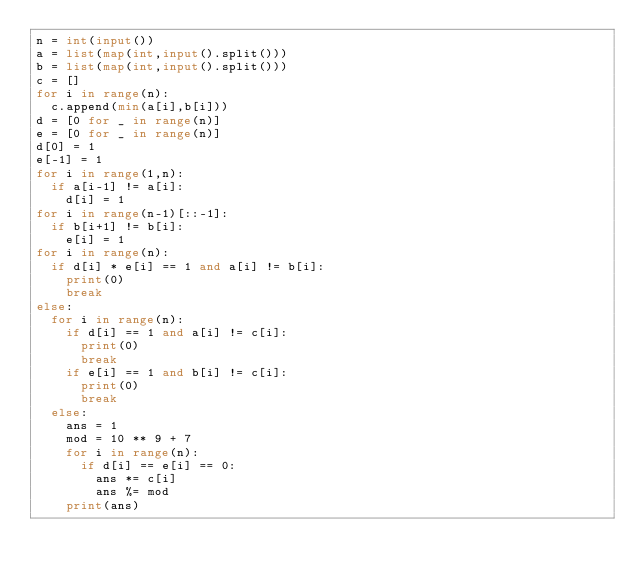Convert code to text. <code><loc_0><loc_0><loc_500><loc_500><_Python_>n = int(input())
a = list(map(int,input().split()))
b = list(map(int,input().split()))
c = []
for i in range(n):
  c.append(min(a[i],b[i]))
d = [0 for _ in range(n)]
e = [0 for _ in range(n)]
d[0] = 1
e[-1] = 1
for i in range(1,n):
  if a[i-1] != a[i]:
    d[i] = 1
for i in range(n-1)[::-1]:
  if b[i+1] != b[i]:
    e[i] = 1
for i in range(n):
  if d[i] * e[i] == 1 and a[i] != b[i]:
    print(0)
    break
else:
  for i in range(n):
    if d[i] == 1 and a[i] != c[i]:
      print(0)
      break
    if e[i] == 1 and b[i] != c[i]:
      print(0)
      break
  else:
    ans = 1
    mod = 10 ** 9 + 7
    for i in range(n):
      if d[i] == e[i] == 0:
        ans *= c[i]
        ans %= mod
    print(ans)</code> 